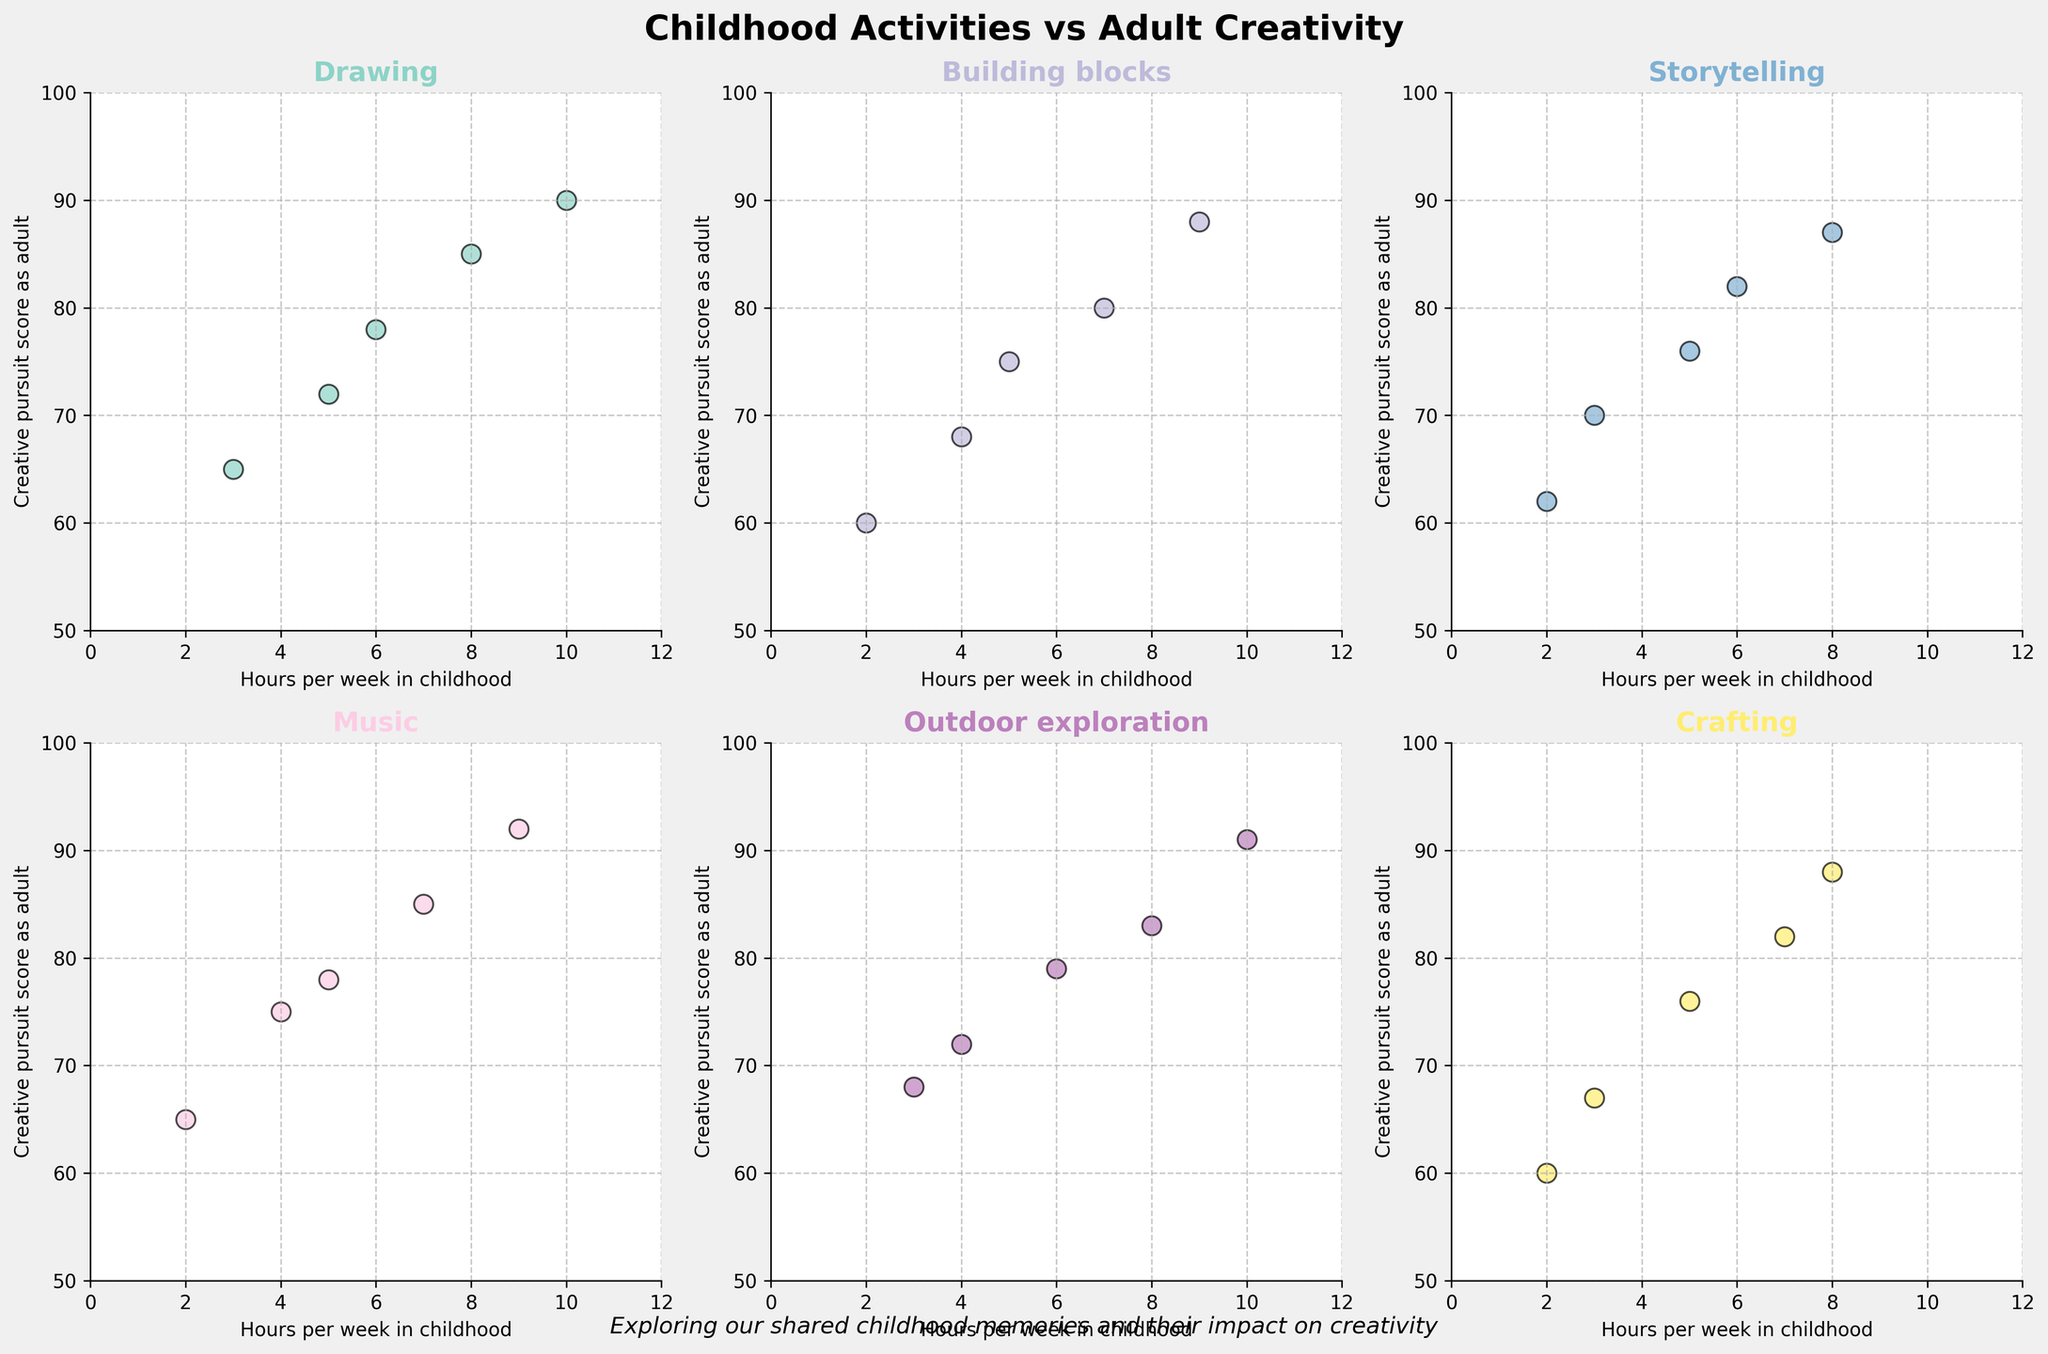What is the general trend between the hours spent on drawing in childhood and the creative pursuit scores in adulthood? Looking at the scatter plot for 'Drawing', as the hours per week spent in childhood increase, there is a noticeable upward trend in the creative pursuit scores in adulthood. This indicates a positive correlation.
Answer: Positive correlation Which activity shows the highest score variance in creative pursuits as adults? By comparing the range of creative pursuit scores across all activities, 'Music' shows scores from 65 to 92, indicating the largest variance.
Answer: Music Is there any activity for which an increase in hours per week doesn't correlate with an increase in creative pursuit scores? Observing the scatter plots, 'Music' and 'Outdoor exploration' both have one or two points where higher hours per week do not correspond to a higher score, but generally there is a positive correlation. Overall, every activity shows some level of correlation.
Answer: No clear negative correlation For 'Storytelling', what are the creative pursuit scores corresponding to 2 and 8 hours per week, and what is their difference? From the 'Storytelling' subplot, for 2 hours per week, the score is 62, and for 8 hours per week, it is 87. The difference is 87 - 62 = 25.
Answer: 25 Which activity shows scores clustering closely together with respect to hours spent per week? 'Crafting' has scores that are clustered more closely together between 60 and 88, showing less variance compared to other activities.
Answer: Crafting Are there any activities where spending fewer than 3 hours per week results in a high creative pursuit score as an adult? The 'Outdoor exploration' activity shows a high creative pursuit score (68) for 3 hours per week, which is relatively high compared to other scores for less time invested in the activity.
Answer: Outdoor exploration Is the relationship between childhood hours and adult creative pursuits more linear or more scattered for 'Building blocks'? The 'Building blocks' subplot shows a scattered relationship with no clear linear trend, as the scores vary for the given hours.
Answer: Scattered What is the median creative pursuit score for "Drawing"? The scores for 'Drawing' are 72, 85, 65, 90, and 78. Arranging them in order: 65, 72, 78, 85, 90, the median value here is the third value, which is 78.
Answer: 78 